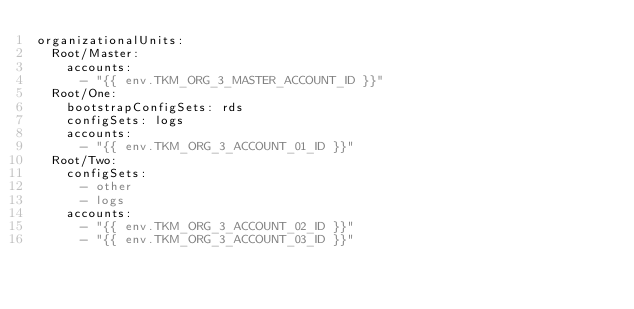<code> <loc_0><loc_0><loc_500><loc_500><_YAML_>organizationalUnits:
  Root/Master:
    accounts:
      - "{{ env.TKM_ORG_3_MASTER_ACCOUNT_ID }}"
  Root/One:
    bootstrapConfigSets: rds
    configSets: logs
    accounts:
      - "{{ env.TKM_ORG_3_ACCOUNT_01_ID }}"
  Root/Two:
    configSets:
      - other
      - logs
    accounts:
      - "{{ env.TKM_ORG_3_ACCOUNT_02_ID }}"
      - "{{ env.TKM_ORG_3_ACCOUNT_03_ID }}"
</code> 